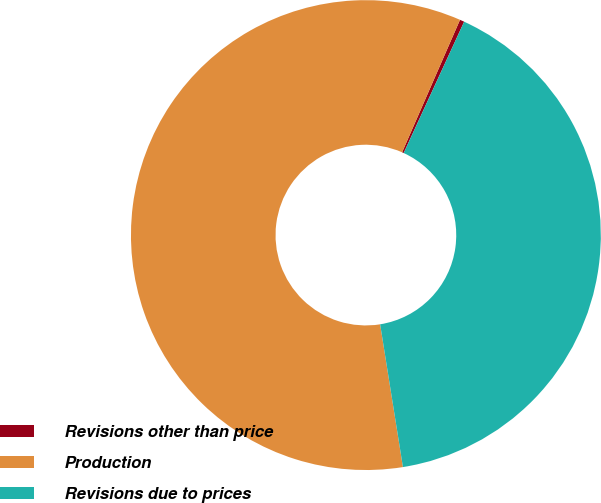Convert chart. <chart><loc_0><loc_0><loc_500><loc_500><pie_chart><fcel>Revisions other than price<fcel>Production<fcel>Revisions due to prices<nl><fcel>0.31%<fcel>59.08%<fcel>40.61%<nl></chart> 